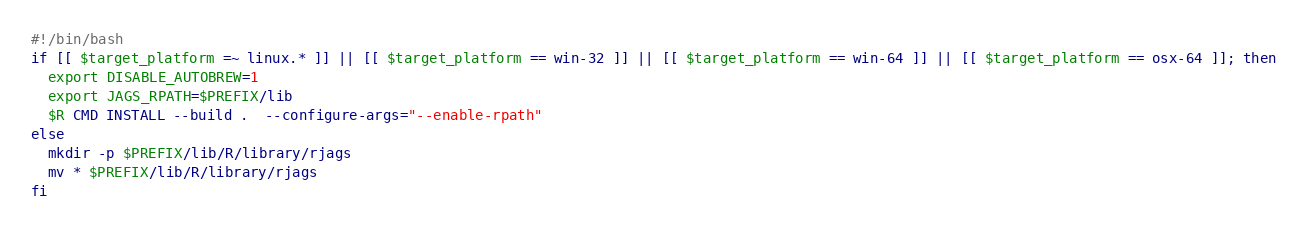Convert code to text. <code><loc_0><loc_0><loc_500><loc_500><_Bash_>#!/bin/bash
if [[ $target_platform =~ linux.* ]] || [[ $target_platform == win-32 ]] || [[ $target_platform == win-64 ]] || [[ $target_platform == osx-64 ]]; then
  export DISABLE_AUTOBREW=1
  export JAGS_RPATH=$PREFIX/lib
  $R CMD INSTALL --build .  --configure-args="--enable-rpath"
else
  mkdir -p $PREFIX/lib/R/library/rjags
  mv * $PREFIX/lib/R/library/rjags
fi
</code> 